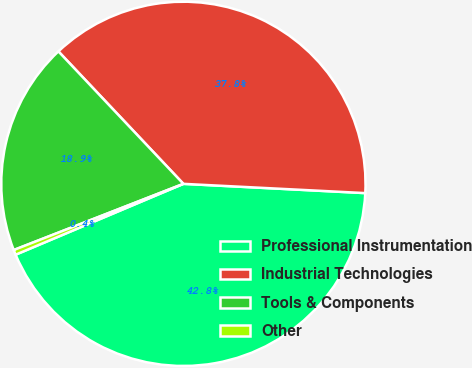Convert chart to OTSL. <chart><loc_0><loc_0><loc_500><loc_500><pie_chart><fcel>Professional Instrumentation<fcel>Industrial Technologies<fcel>Tools & Components<fcel>Other<nl><fcel>42.83%<fcel>37.85%<fcel>18.88%<fcel>0.44%<nl></chart> 